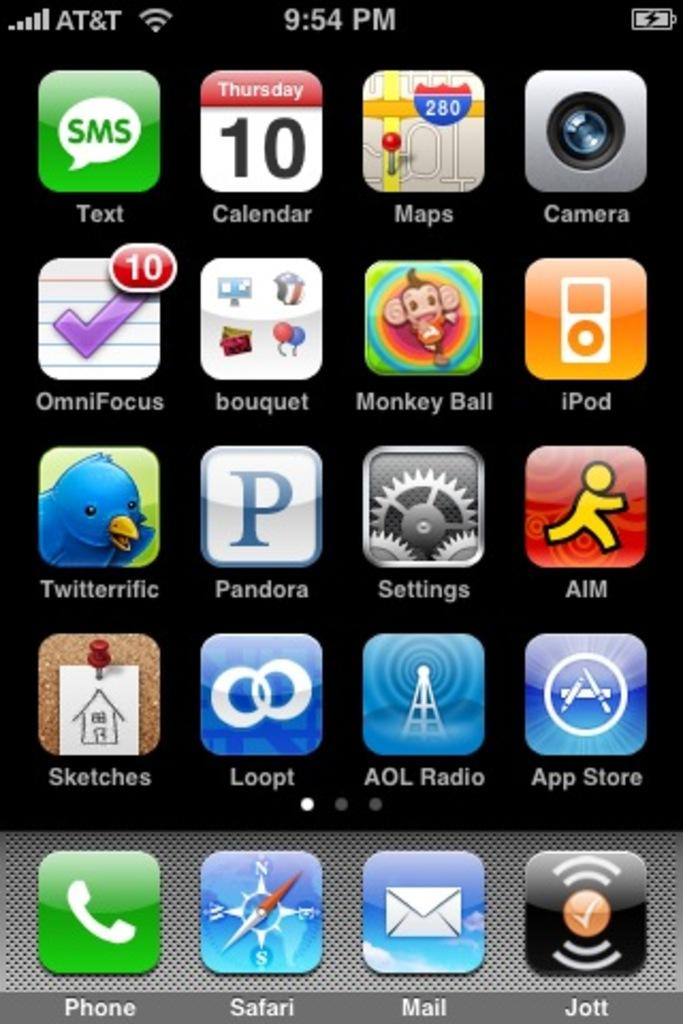<image>
Relay a brief, clear account of the picture shown. The homescreen of a cell phones shows the icons for Twitterific and Loopt. 